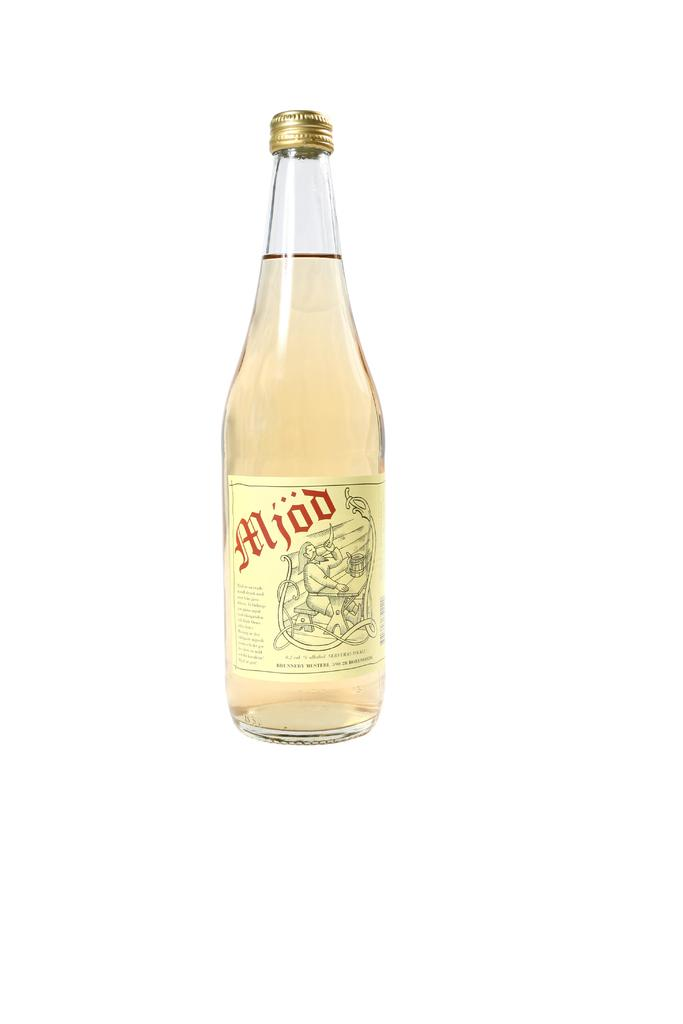<image>
Describe the image concisely. Bottle of Mjod shows a man at a table drinking from a horn. 